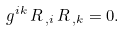<formula> <loc_0><loc_0><loc_500><loc_500>g ^ { i k } \, R _ { \, , i } \, R _ { \, , k } = 0 .</formula> 